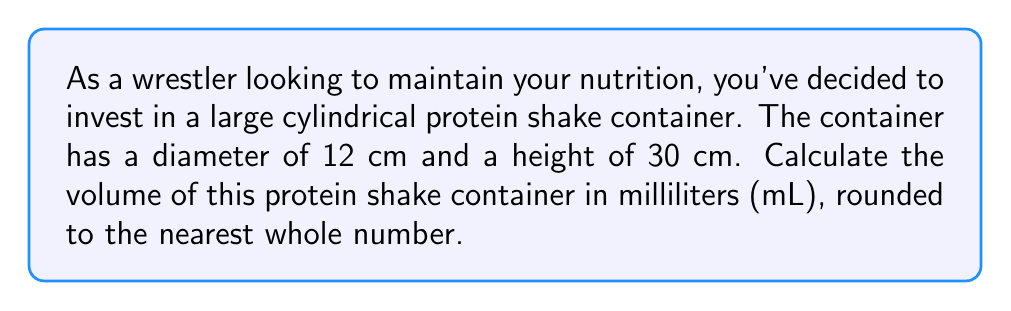Teach me how to tackle this problem. To calculate the volume of a cylindrical container, we need to use the formula for the volume of a cylinder:

$$V = \pi r^2 h$$

Where:
$V$ = volume
$\pi$ = pi (approximately 3.14159)
$r$ = radius of the base
$h$ = height of the cylinder

Given:
- Diameter = 12 cm
- Height = 30 cm

Step 1: Calculate the radius
The radius is half the diameter:
$r = 12 \div 2 = 6$ cm

Step 2: Apply the volume formula
$$V = \pi (6 \text{ cm})^2 (30 \text{ cm})$$

Step 3: Calculate
$$V = \pi \cdot 36 \text{ cm}^2 \cdot 30 \text{ cm}$$
$$V = 1080\pi \text{ cm}^3$$

Step 4: Evaluate $\pi$ and convert to mL
$$V \approx 1080 \cdot 3.14159 \text{ cm}^3$$
$$V \approx 3392.92 \text{ cm}^3$$

Note that 1 cm³ = 1 mL, so our result is already in mL.

Step 5: Round to the nearest whole number
$$V \approx 3393 \text{ mL}$$
Answer: 3393 mL 